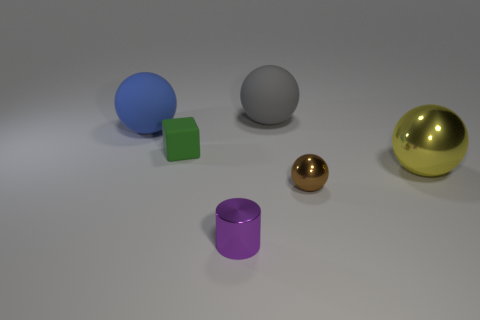Add 3 small brown metallic blocks. How many objects exist? 9 Subtract all blocks. How many objects are left? 5 Add 4 green cubes. How many green cubes are left? 5 Add 6 small purple cylinders. How many small purple cylinders exist? 7 Subtract 0 red cubes. How many objects are left? 6 Subtract all small cyan things. Subtract all big rubber objects. How many objects are left? 4 